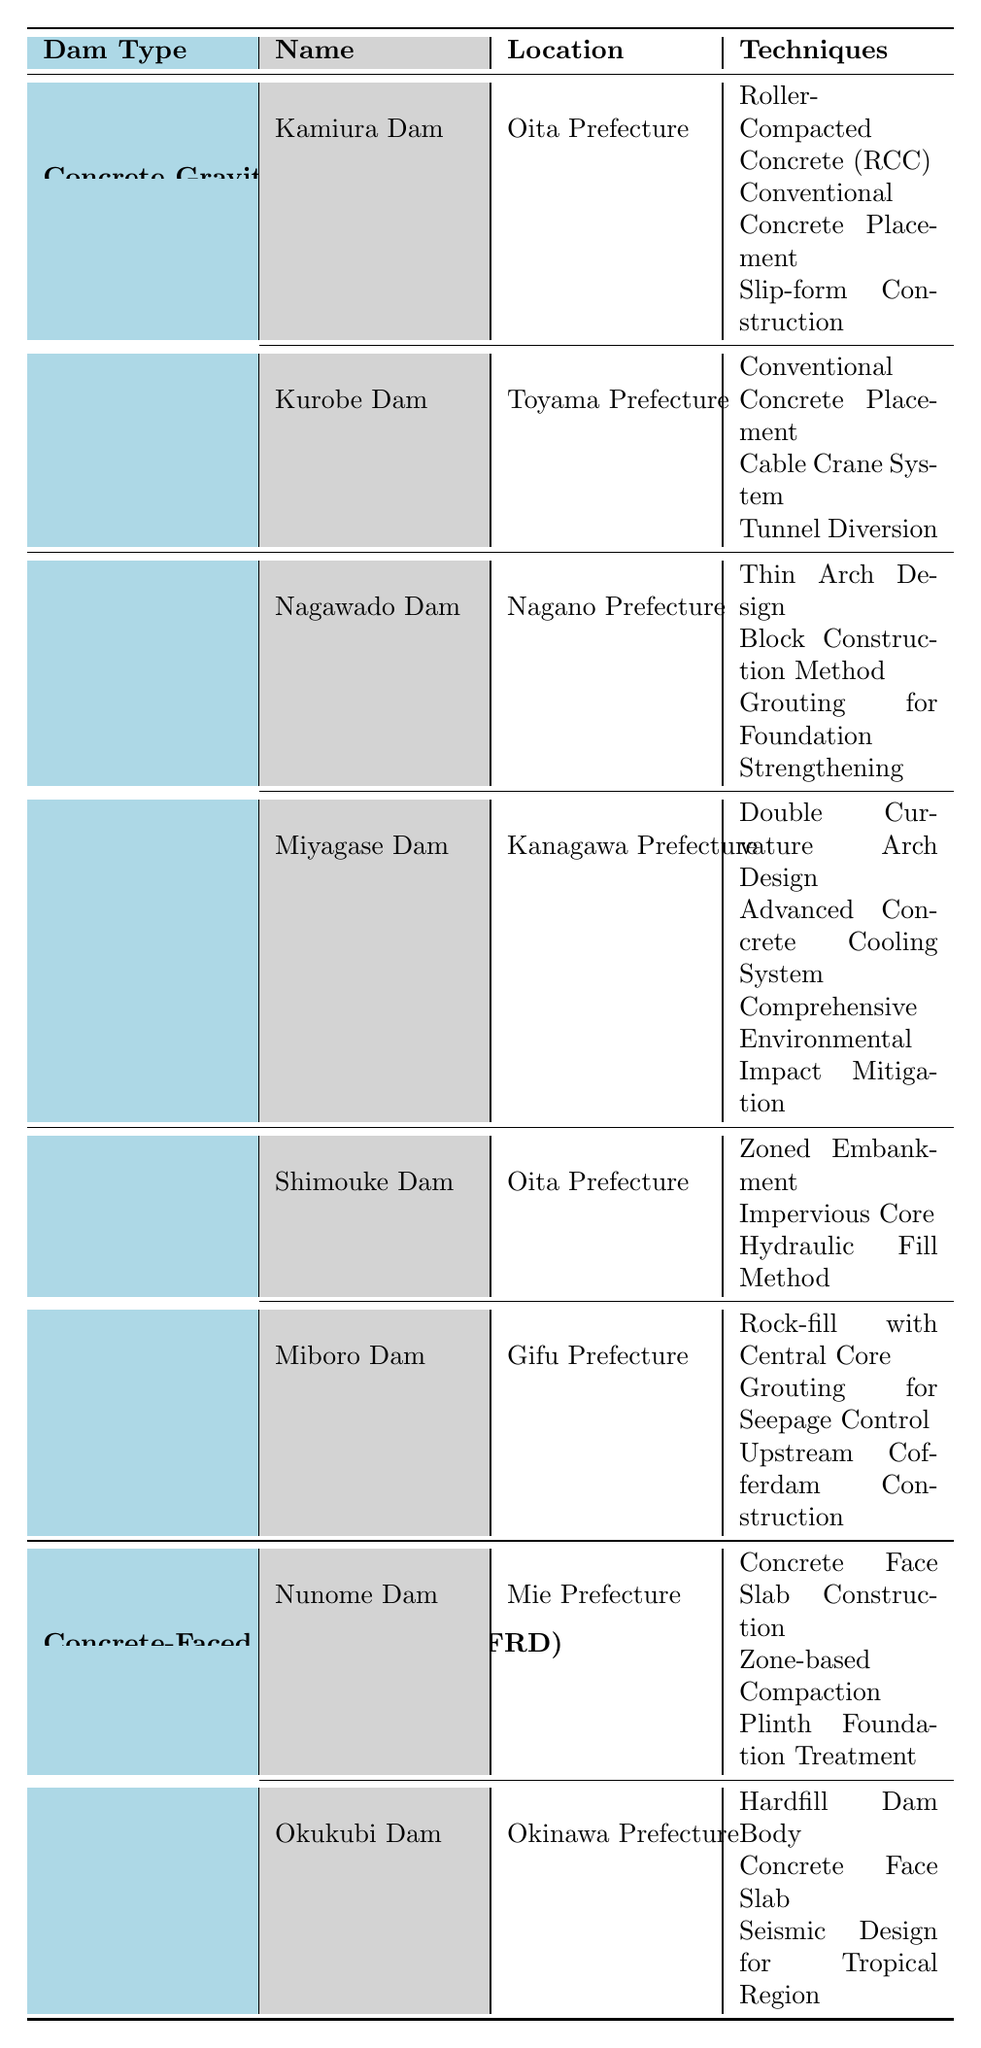What construction techniques were used for the Kamiura Dam? The table lists three techniques used in the construction of Kamiura Dam: Roller-Compacted Concrete (RCC), Conventional Concrete Placement, and Slip-form Construction.
Answer: Roller-Compacted Concrete (RCC), Conventional Concrete Placement, Slip-form Construction Which dam is located in Toyama Prefecture and what construction method was primarily used? The table shows that Kurobe Dam is located in Toyama Prefecture. Its primary construction methods included Conventional Concrete Placement, a Cable Crane System, and Tunnel Diversion.
Answer: Kurobe Dam; Conventional Concrete Placement Did both the Nagawado Dam and Miyagase Dam utilize advanced concrete cooling systems? By referring to the table, it is clear that only Miyagase Dam utilized an Advanced Concrete Cooling System, while Nagawado Dam used a Thin Arch Design, Block Construction Method, and Grouting for Foundation Strengthening.
Answer: No What is the total number of different construction techniques used for the Rockfill Dams listed in the table? The table lists two Rockfill Dams: Shimouke Dam and Miboro Dam, each with three unique techniques. Therefore, the total number of unique techniques is 3 (Shimouke) + 3 (Miboro) = 6.
Answer: 6 Which type of dam has the most listed examples? Examining the table, Concrete Gravity Dam type has two examples (Kamiura Dam, Kurobe Dam), while Arch Dam, Rockfill Dam, and Concrete-Faced Rockfill Dam types also have two. Hence, no dam type has more than two examples.
Answer: None, all types have the same number What percentage of the dams listed utilized a concrete face slab construction technique? There are a total of 8 dams listed, with 2 (Nunome Dam, Okukubi Dam) utilizing a Concrete Face Slab Construction technique. Therefore, the percentage is (2/8) * 100 = 25%.
Answer: 25% Is it true that the Miboro Dam employed grouting for seepage control? Yes, the table explicitly states that one of the techniques used in the construction of Miboro Dam is grouting for seepage control.
Answer: Yes Which dam type used techniques related to environmental impact mitigation? The table reveals that only Miyagase Dam, under the Arch Dam category, used the technique of Comprehensive Environmental Impact Mitigation.
Answer: Arch Dam; Miyagase Dam How many unique techniques were used for the construction of Concrete-Faced Rockfill Dams? The table lists two examples of Concrete-Faced Rockfill Dams (Nunome Dam and Okukubi Dam), each with three different techniques. Therefore, the total unique techniques are 3 (Nunome) + 3 (Okukubi) = 6.
Answer: 6 What is the construction period for the Shimouke Dam? According to the table, the construction period for Shimouke Dam is from 1966 to 1973.
Answer: 1966-1973 